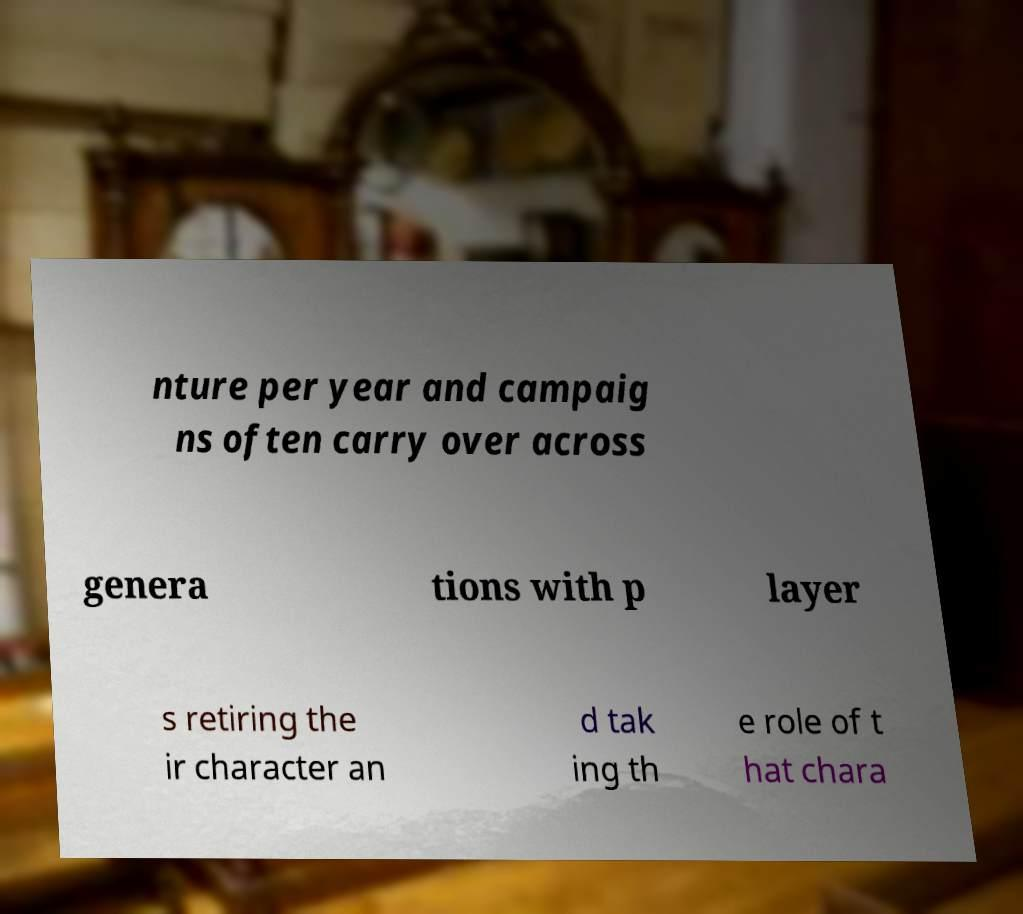Could you extract and type out the text from this image? nture per year and campaig ns often carry over across genera tions with p layer s retiring the ir character an d tak ing th e role of t hat chara 